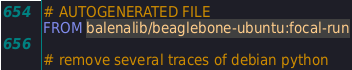Convert code to text. <code><loc_0><loc_0><loc_500><loc_500><_Dockerfile_># AUTOGENERATED FILE
FROM balenalib/beaglebone-ubuntu:focal-run

# remove several traces of debian python</code> 